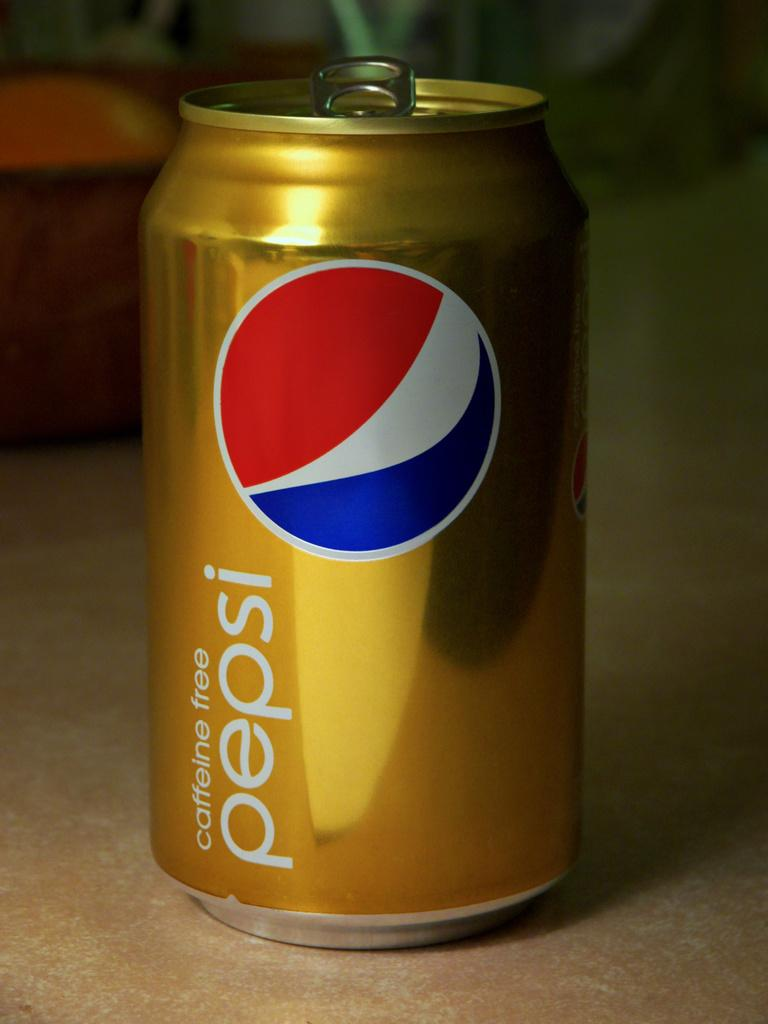<image>
Render a clear and concise summary of the photo. a pepsi can that is gold in color 